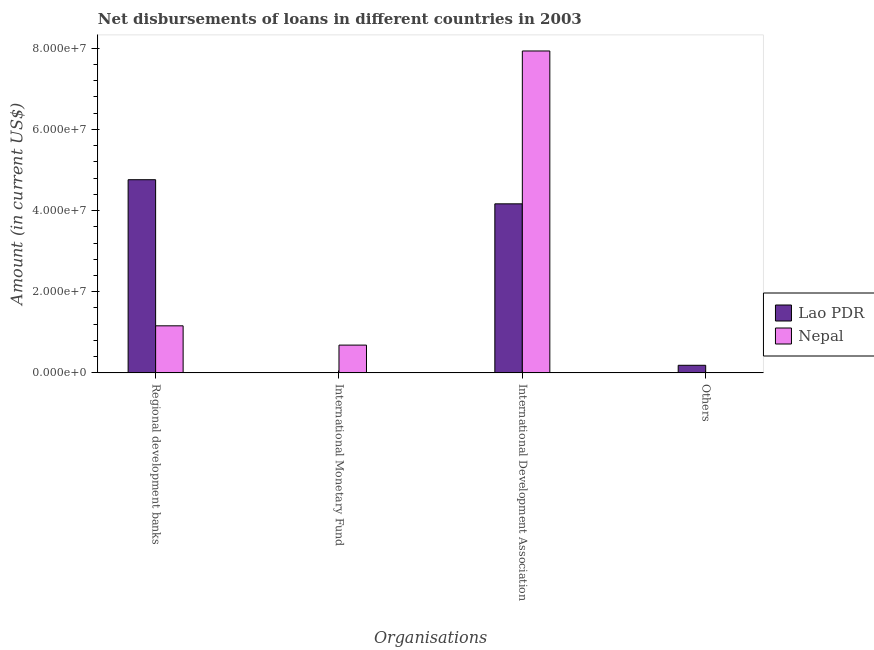How many bars are there on the 3rd tick from the right?
Ensure brevity in your answer.  1. What is the label of the 2nd group of bars from the left?
Keep it short and to the point. International Monetary Fund. What is the amount of loan disimbursed by regional development banks in Lao PDR?
Make the answer very short. 4.76e+07. Across all countries, what is the maximum amount of loan disimbursed by other organisations?
Provide a succinct answer. 1.87e+06. Across all countries, what is the minimum amount of loan disimbursed by international monetary fund?
Keep it short and to the point. 0. In which country was the amount of loan disimbursed by international monetary fund maximum?
Make the answer very short. Nepal. What is the total amount of loan disimbursed by regional development banks in the graph?
Your response must be concise. 5.92e+07. What is the difference between the amount of loan disimbursed by regional development banks in Nepal and that in Lao PDR?
Offer a very short reply. -3.60e+07. What is the difference between the amount of loan disimbursed by other organisations in Nepal and the amount of loan disimbursed by international development association in Lao PDR?
Provide a short and direct response. -4.17e+07. What is the average amount of loan disimbursed by international development association per country?
Make the answer very short. 6.05e+07. What is the difference between the amount of loan disimbursed by other organisations and amount of loan disimbursed by regional development banks in Lao PDR?
Offer a terse response. -4.57e+07. What is the ratio of the amount of loan disimbursed by regional development banks in Nepal to that in Lao PDR?
Ensure brevity in your answer.  0.24. What is the difference between the highest and the second highest amount of loan disimbursed by international development association?
Your answer should be very brief. 3.77e+07. What is the difference between the highest and the lowest amount of loan disimbursed by international monetary fund?
Give a very brief answer. 6.84e+06. How many bars are there?
Provide a short and direct response. 6. How many countries are there in the graph?
Your response must be concise. 2. What is the difference between two consecutive major ticks on the Y-axis?
Make the answer very short. 2.00e+07. Does the graph contain grids?
Make the answer very short. No. How many legend labels are there?
Make the answer very short. 2. How are the legend labels stacked?
Provide a short and direct response. Vertical. What is the title of the graph?
Offer a very short reply. Net disbursements of loans in different countries in 2003. Does "Belize" appear as one of the legend labels in the graph?
Provide a short and direct response. No. What is the label or title of the X-axis?
Ensure brevity in your answer.  Organisations. What is the label or title of the Y-axis?
Offer a very short reply. Amount (in current US$). What is the Amount (in current US$) of Lao PDR in Regional development banks?
Your response must be concise. 4.76e+07. What is the Amount (in current US$) in Nepal in Regional development banks?
Your answer should be very brief. 1.16e+07. What is the Amount (in current US$) of Nepal in International Monetary Fund?
Provide a succinct answer. 6.84e+06. What is the Amount (in current US$) of Lao PDR in International Development Association?
Offer a terse response. 4.17e+07. What is the Amount (in current US$) of Nepal in International Development Association?
Ensure brevity in your answer.  7.93e+07. What is the Amount (in current US$) in Lao PDR in Others?
Offer a terse response. 1.87e+06. Across all Organisations, what is the maximum Amount (in current US$) in Lao PDR?
Your answer should be very brief. 4.76e+07. Across all Organisations, what is the maximum Amount (in current US$) of Nepal?
Your answer should be compact. 7.93e+07. Across all Organisations, what is the minimum Amount (in current US$) in Nepal?
Provide a succinct answer. 0. What is the total Amount (in current US$) of Lao PDR in the graph?
Your response must be concise. 9.11e+07. What is the total Amount (in current US$) in Nepal in the graph?
Your answer should be very brief. 9.78e+07. What is the difference between the Amount (in current US$) of Nepal in Regional development banks and that in International Monetary Fund?
Your answer should be compact. 4.75e+06. What is the difference between the Amount (in current US$) in Lao PDR in Regional development banks and that in International Development Association?
Offer a very short reply. 5.94e+06. What is the difference between the Amount (in current US$) of Nepal in Regional development banks and that in International Development Association?
Offer a very short reply. -6.77e+07. What is the difference between the Amount (in current US$) of Lao PDR in Regional development banks and that in Others?
Ensure brevity in your answer.  4.57e+07. What is the difference between the Amount (in current US$) of Nepal in International Monetary Fund and that in International Development Association?
Make the answer very short. -7.25e+07. What is the difference between the Amount (in current US$) in Lao PDR in International Development Association and that in Others?
Give a very brief answer. 3.98e+07. What is the difference between the Amount (in current US$) in Lao PDR in Regional development banks and the Amount (in current US$) in Nepal in International Monetary Fund?
Offer a very short reply. 4.08e+07. What is the difference between the Amount (in current US$) in Lao PDR in Regional development banks and the Amount (in current US$) in Nepal in International Development Association?
Give a very brief answer. -3.17e+07. What is the average Amount (in current US$) of Lao PDR per Organisations?
Offer a very short reply. 2.28e+07. What is the average Amount (in current US$) in Nepal per Organisations?
Give a very brief answer. 2.44e+07. What is the difference between the Amount (in current US$) of Lao PDR and Amount (in current US$) of Nepal in Regional development banks?
Offer a very short reply. 3.60e+07. What is the difference between the Amount (in current US$) of Lao PDR and Amount (in current US$) of Nepal in International Development Association?
Ensure brevity in your answer.  -3.77e+07. What is the ratio of the Amount (in current US$) in Nepal in Regional development banks to that in International Monetary Fund?
Offer a very short reply. 1.69. What is the ratio of the Amount (in current US$) in Lao PDR in Regional development banks to that in International Development Association?
Your answer should be compact. 1.14. What is the ratio of the Amount (in current US$) of Nepal in Regional development banks to that in International Development Association?
Provide a short and direct response. 0.15. What is the ratio of the Amount (in current US$) in Lao PDR in Regional development banks to that in Others?
Offer a terse response. 25.51. What is the ratio of the Amount (in current US$) in Nepal in International Monetary Fund to that in International Development Association?
Keep it short and to the point. 0.09. What is the ratio of the Amount (in current US$) of Lao PDR in International Development Association to that in Others?
Provide a short and direct response. 22.32. What is the difference between the highest and the second highest Amount (in current US$) in Lao PDR?
Ensure brevity in your answer.  5.94e+06. What is the difference between the highest and the second highest Amount (in current US$) in Nepal?
Make the answer very short. 6.77e+07. What is the difference between the highest and the lowest Amount (in current US$) of Lao PDR?
Give a very brief answer. 4.76e+07. What is the difference between the highest and the lowest Amount (in current US$) of Nepal?
Ensure brevity in your answer.  7.93e+07. 